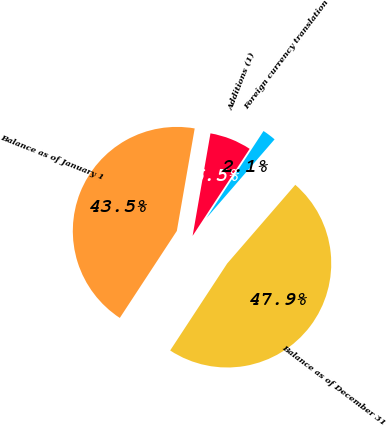<chart> <loc_0><loc_0><loc_500><loc_500><pie_chart><fcel>Balance as of January 1<fcel>Additions (1)<fcel>Foreign currency translation<fcel>Balance as of December 31<nl><fcel>43.51%<fcel>6.49%<fcel>2.12%<fcel>47.88%<nl></chart> 